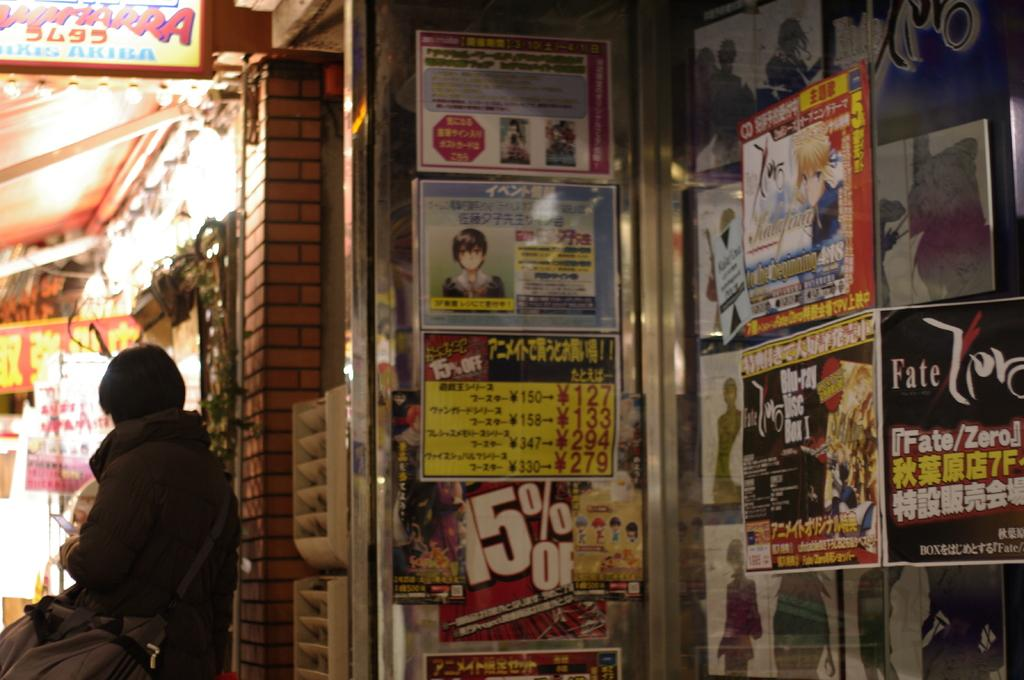What is attached to the wall in the image? There are advertisements attached to the wall in the image. Can you describe the person in the image? There is a person standing on the floor in the image. What type of structure is visible in the image? There is a shed in the image. How many feet are visible in the image? There is no mention of feet in the image, as the focus is on the advertisements, person, and shed. What time of day is depicted in the image? The time of day is not mentioned in the image, so it cannot be determined. 